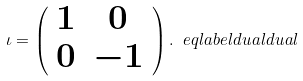<formula> <loc_0><loc_0><loc_500><loc_500>\iota = \left ( \begin{array} { c c } 1 & 0 \\ 0 & - 1 \end{array} \right ) . \ e q l a b e l { d u a l d u a l }</formula> 